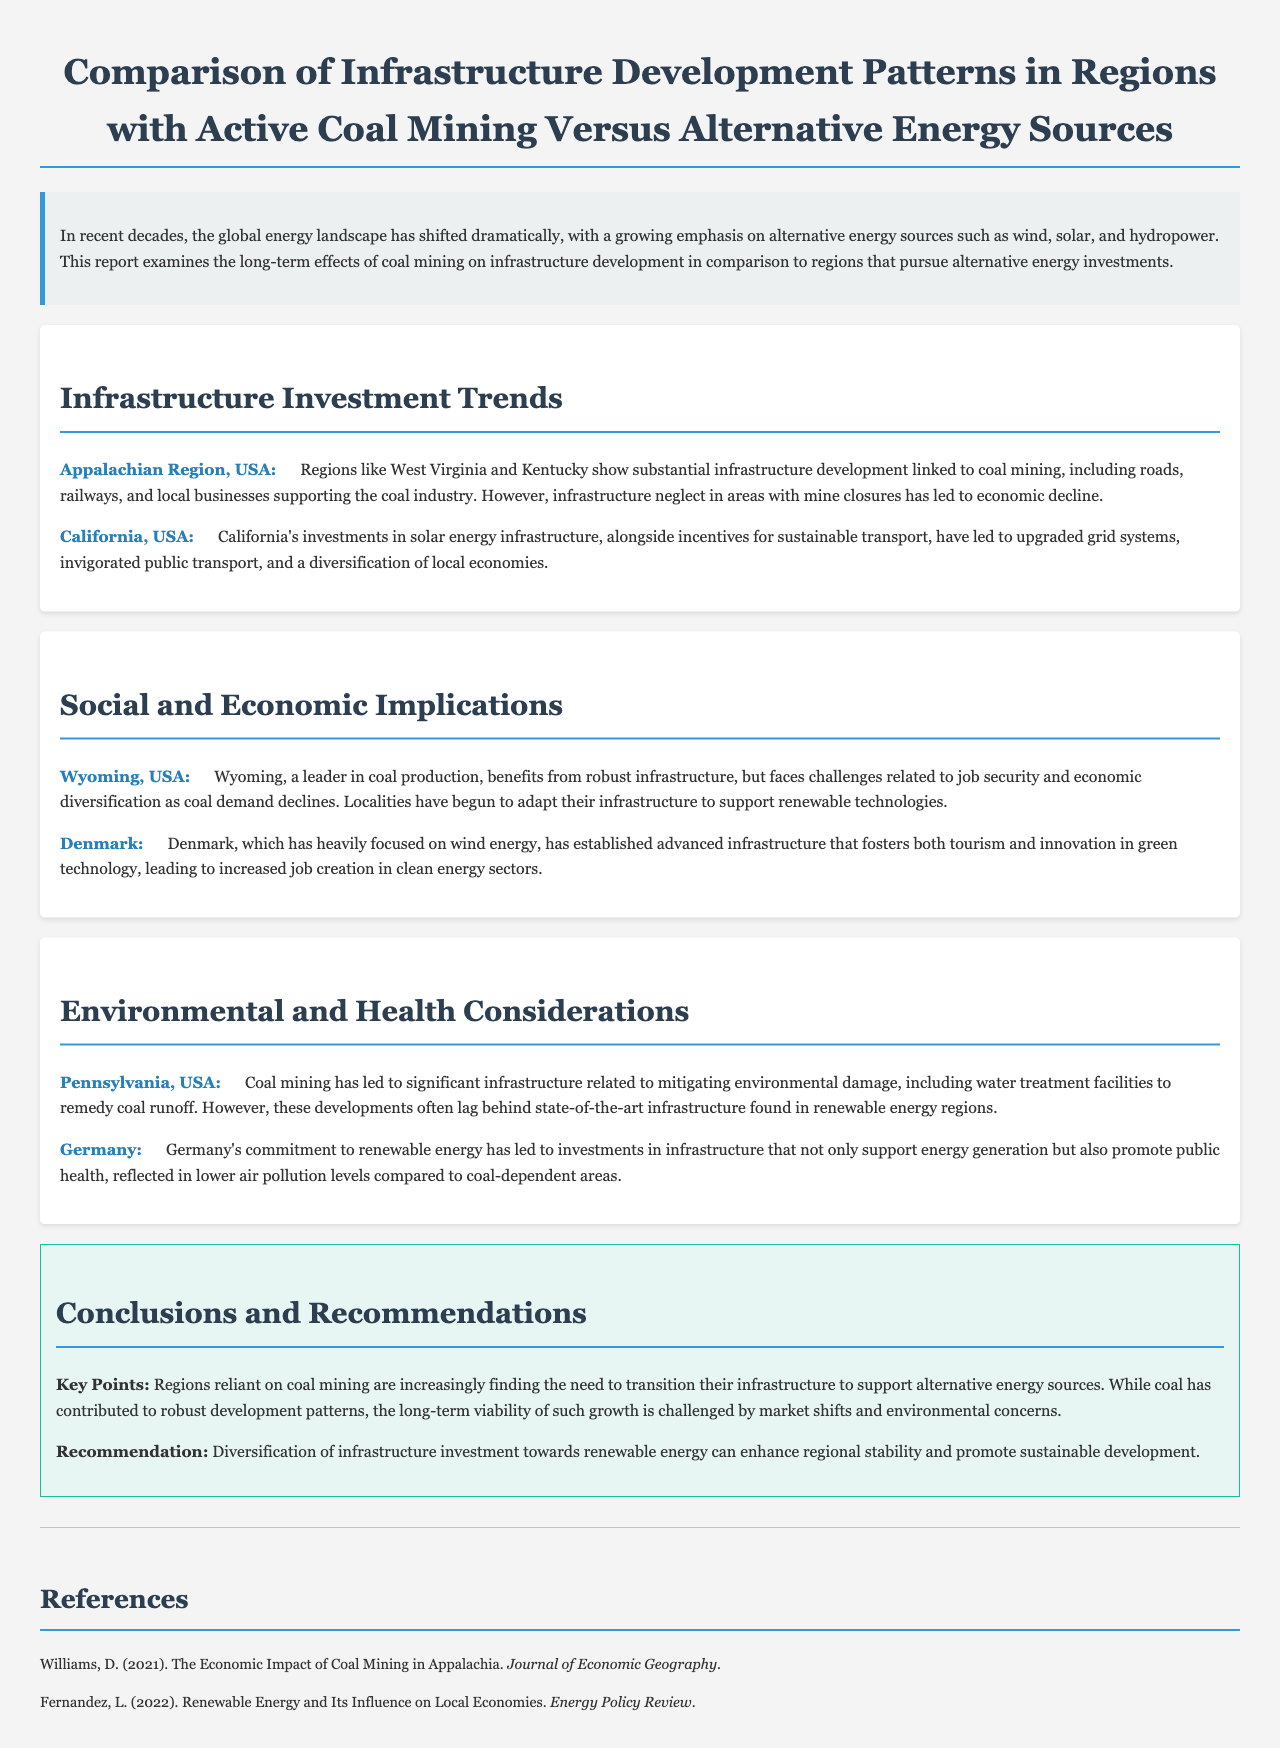What region in the USA shows substantial infrastructure development linked to coal mining? The document states that regions like West Virginia and Kentucky in the Appalachian Region show substantial infrastructure development linked to coal mining.
Answer: Appalachian Region, USA Which country is mentioned as focusing heavily on wind energy? The document highlights Denmark as an example of a country that has heavily focused on wind energy.
Answer: Denmark What is one of the key implications for Wyoming regarding its infrastructure? The findings indicate that Wyoming faces challenges related to job security and economic diversification as coal demand declines.
Answer: Job security and economic diversification According to the report, what has Germany's commitment to renewable energy led to? The document notes that Germany's commitment to renewable energy has led to investments in infrastructure that support energy generation and promote public health.
Answer: Investments in infrastructure What is a recommended strategy for regions reliant on coal mining? The conclusion section recommends diversification of infrastructure investment towards renewable energy to enhance regional stability.
Answer: Diversification of infrastructure investment What has coal mining in Pennsylvania led to regarding infrastructure? The findings state that coal mining has led to significant infrastructure related to mitigating environmental damage, including water treatment facilities.
Answer: Water treatment facilities What type of energy investment has California made according to the report? The document states that California has made investments in solar energy infrastructure.
Answer: Solar energy infrastructure What health benefit is noted in Germany when comparing it to coal-dependent areas? The report mentions that Germany has lower air pollution levels compared to coal-dependent areas.
Answer: Lower air pollution levels 